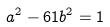<formula> <loc_0><loc_0><loc_500><loc_500>a ^ { 2 } - 6 1 b ^ { 2 } = 1</formula> 